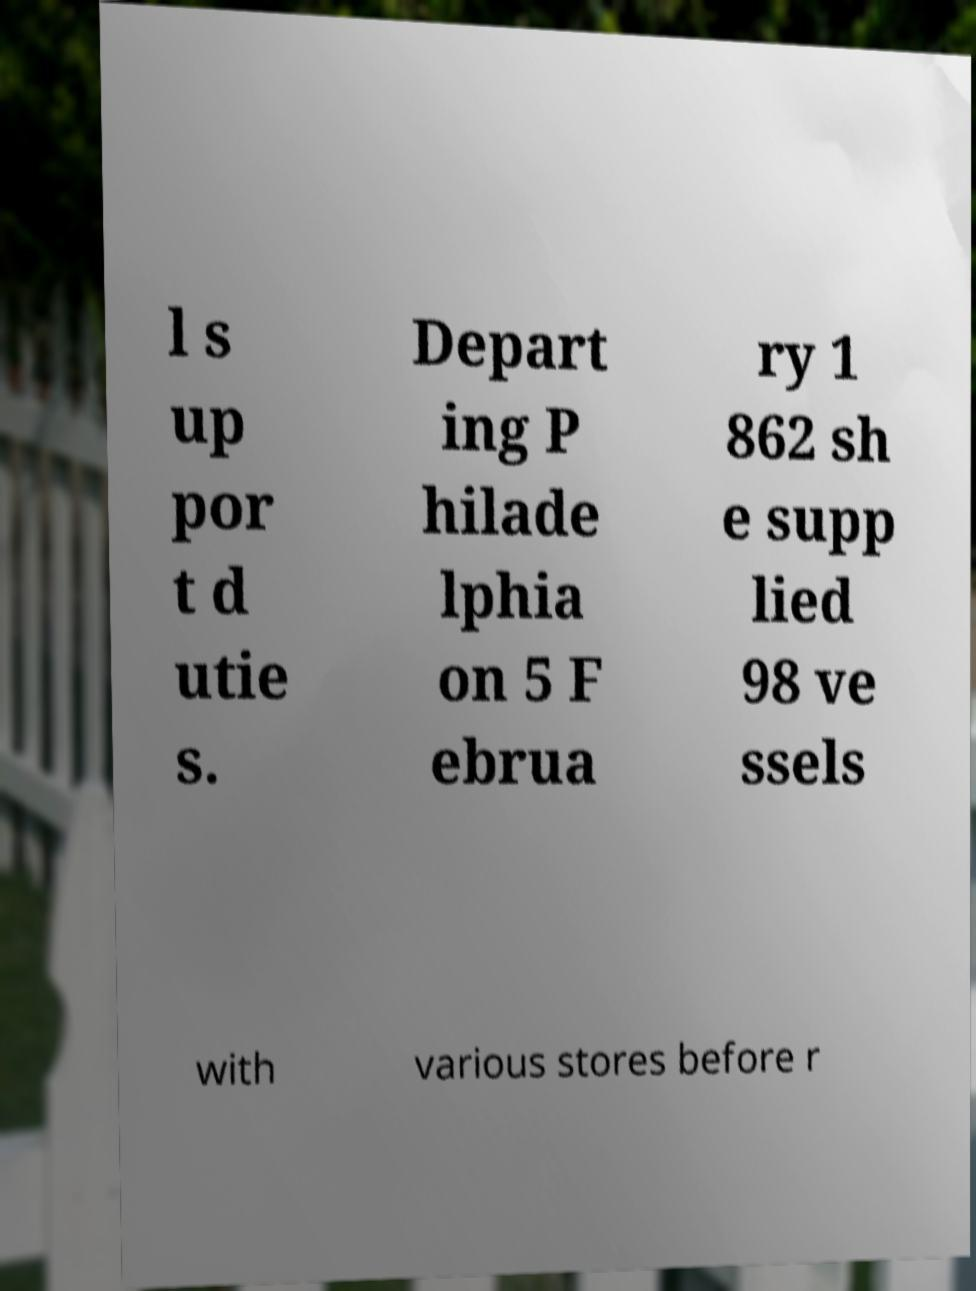For documentation purposes, I need the text within this image transcribed. Could you provide that? l s up por t d utie s. Depart ing P hilade lphia on 5 F ebrua ry 1 862 sh e supp lied 98 ve ssels with various stores before r 